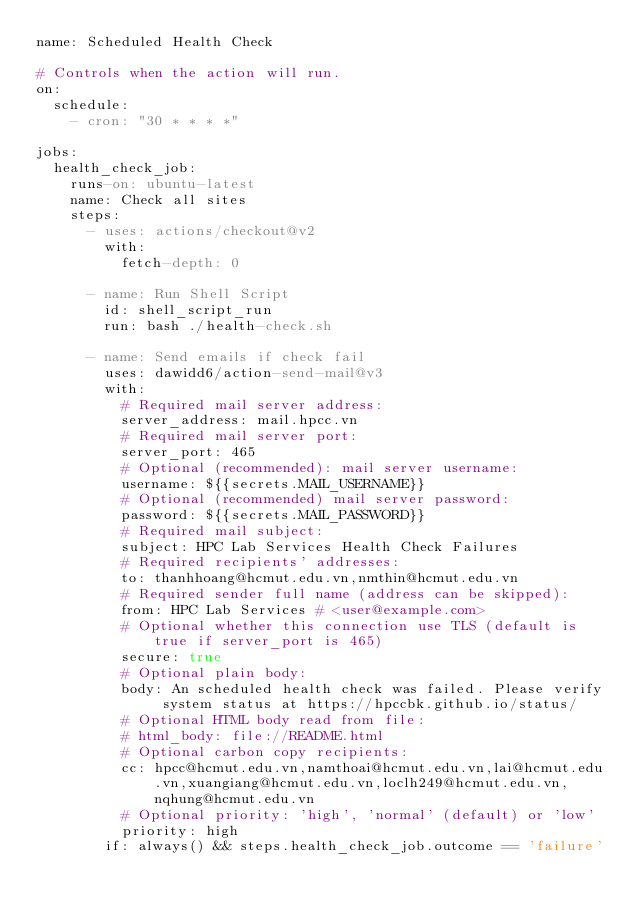<code> <loc_0><loc_0><loc_500><loc_500><_YAML_>name: Scheduled Health Check

# Controls when the action will run.
on:
  schedule:
    - cron: "30 * * * *"

jobs:
  health_check_job:
    runs-on: ubuntu-latest
    name: Check all sites
    steps:
      - uses: actions/checkout@v2
        with:
          fetch-depth: 0

      - name: Run Shell Script
        id: shell_script_run
        run: bash ./health-check.sh

      - name: Send emails if check fail
        uses: dawidd6/action-send-mail@v3
        with:
          # Required mail server address:
          server_address: mail.hpcc.vn
          # Required mail server port:
          server_port: 465
          # Optional (recommended): mail server username:
          username: ${{secrets.MAIL_USERNAME}}
          # Optional (recommended) mail server password:
          password: ${{secrets.MAIL_PASSWORD}}
          # Required mail subject:
          subject: HPC Lab Services Health Check Failures
          # Required recipients' addresses:
          to: thanhhoang@hcmut.edu.vn,nmthin@hcmut.edu.vn
          # Required sender full name (address can be skipped):
          from: HPC Lab Services # <user@example.com>
          # Optional whether this connection use TLS (default is true if server_port is 465)
          secure: true
          # Optional plain body:
          body: An scheduled health check was failed. Please verify system status at https://hpccbk.github.io/status/
          # Optional HTML body read from file:
          # html_body: file://README.html
          # Optional carbon copy recipients:
          cc: hpcc@hcmut.edu.vn,namthoai@hcmut.edu.vn,lai@hcmut.edu.vn,xuangiang@hcmut.edu.vn,loclh249@hcmut.edu.vn,nqhung@hcmut.edu.vn
          # Optional priority: 'high', 'normal' (default) or 'low'
          priority: high
        if: always() && steps.health_check_job.outcome == 'failure'
</code> 